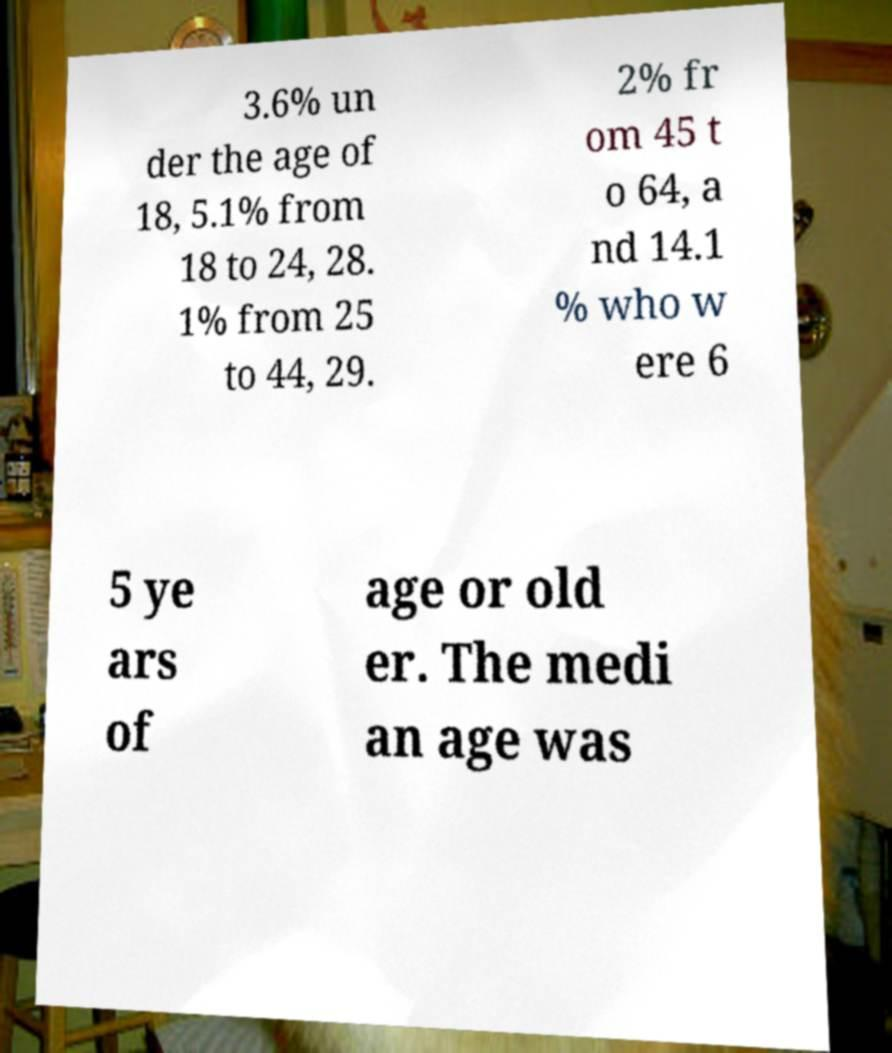Please identify and transcribe the text found in this image. 3.6% un der the age of 18, 5.1% from 18 to 24, 28. 1% from 25 to 44, 29. 2% fr om 45 t o 64, a nd 14.1 % who w ere 6 5 ye ars of age or old er. The medi an age was 